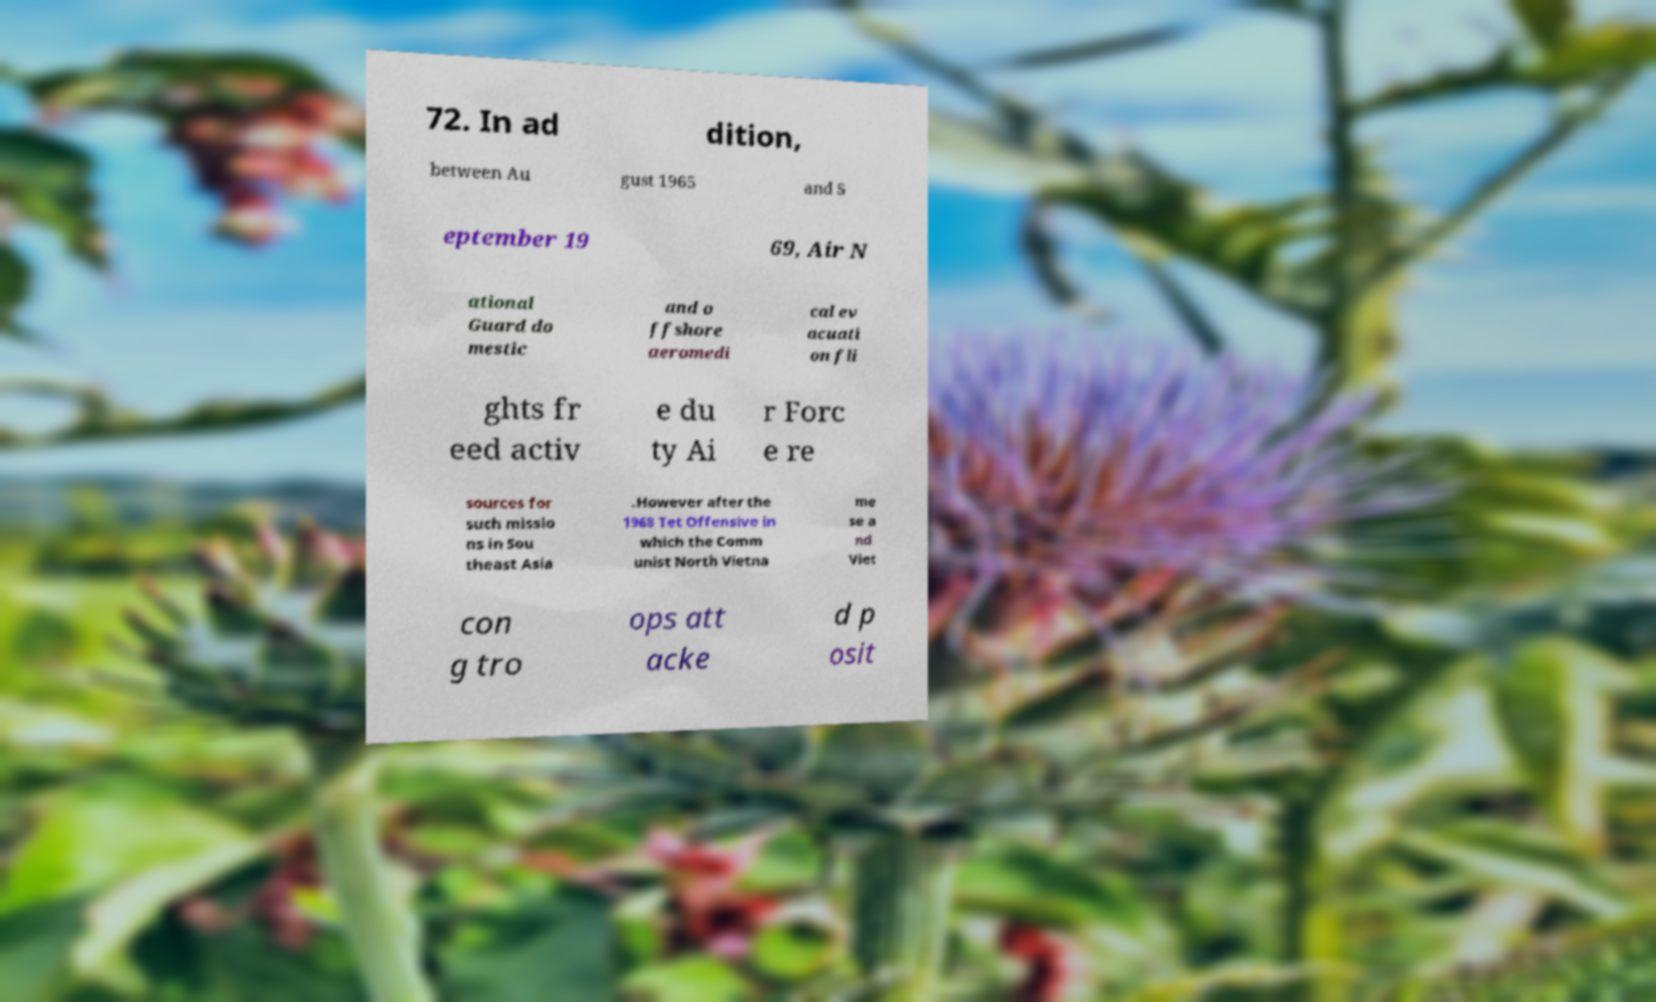For documentation purposes, I need the text within this image transcribed. Could you provide that? 72. In ad dition, between Au gust 1965 and S eptember 19 69, Air N ational Guard do mestic and o ffshore aeromedi cal ev acuati on fli ghts fr eed activ e du ty Ai r Forc e re sources for such missio ns in Sou theast Asia .However after the 1968 Tet Offensive in which the Comm unist North Vietna me se a nd Viet con g tro ops att acke d p osit 